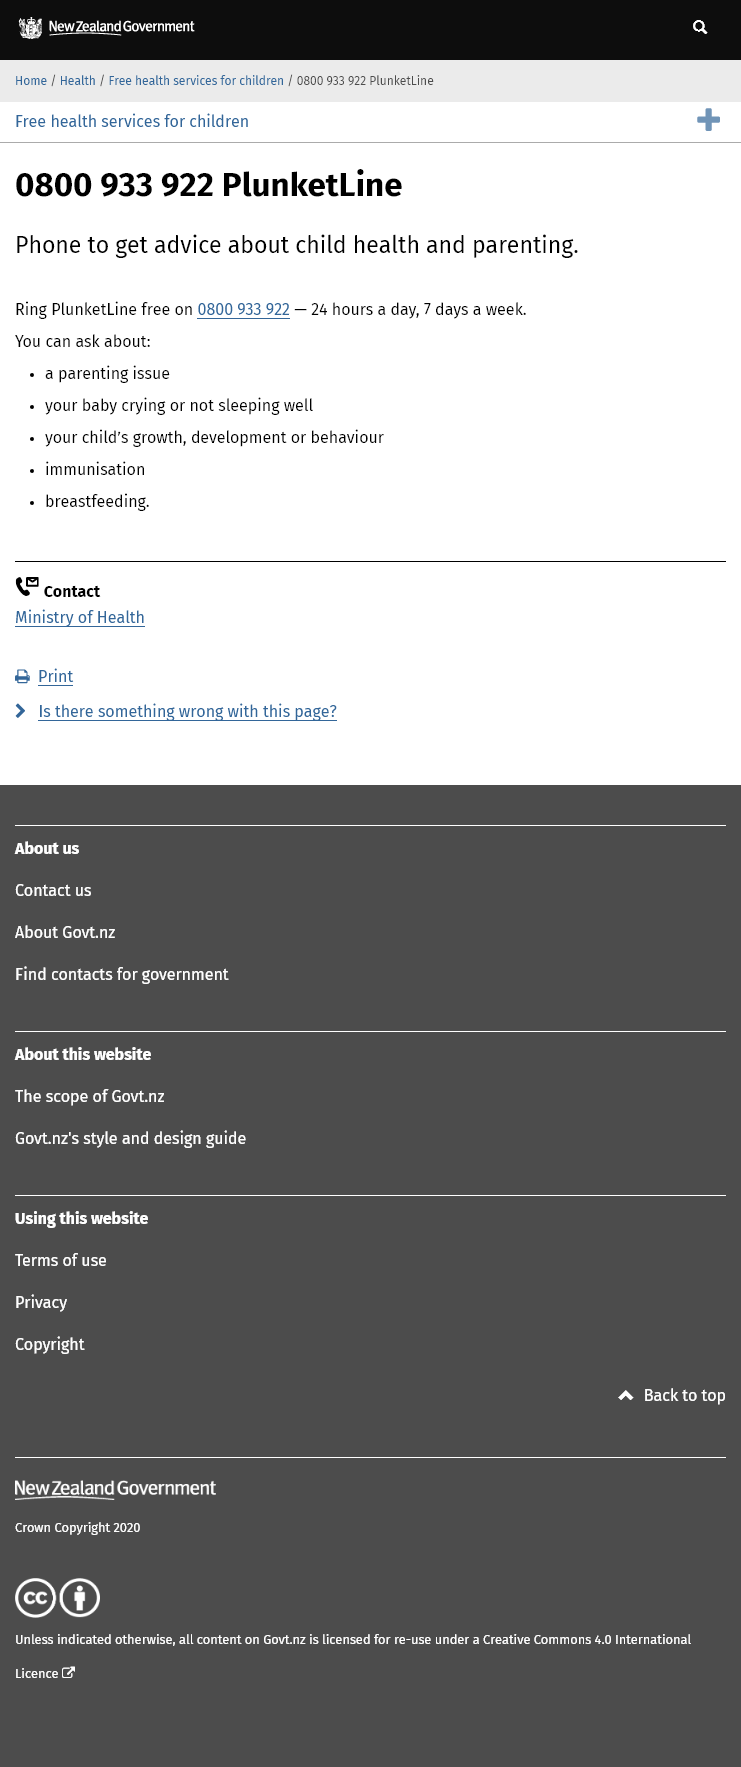Give some essential details in this illustration. It is free to phone PlunketLine. PlunketLine is available 24 hours a day, 7 days a week, for convenient access to support and assistance. The number that one should phone in order to obtain advice regarding child health and parenting is 0800 933 922. 